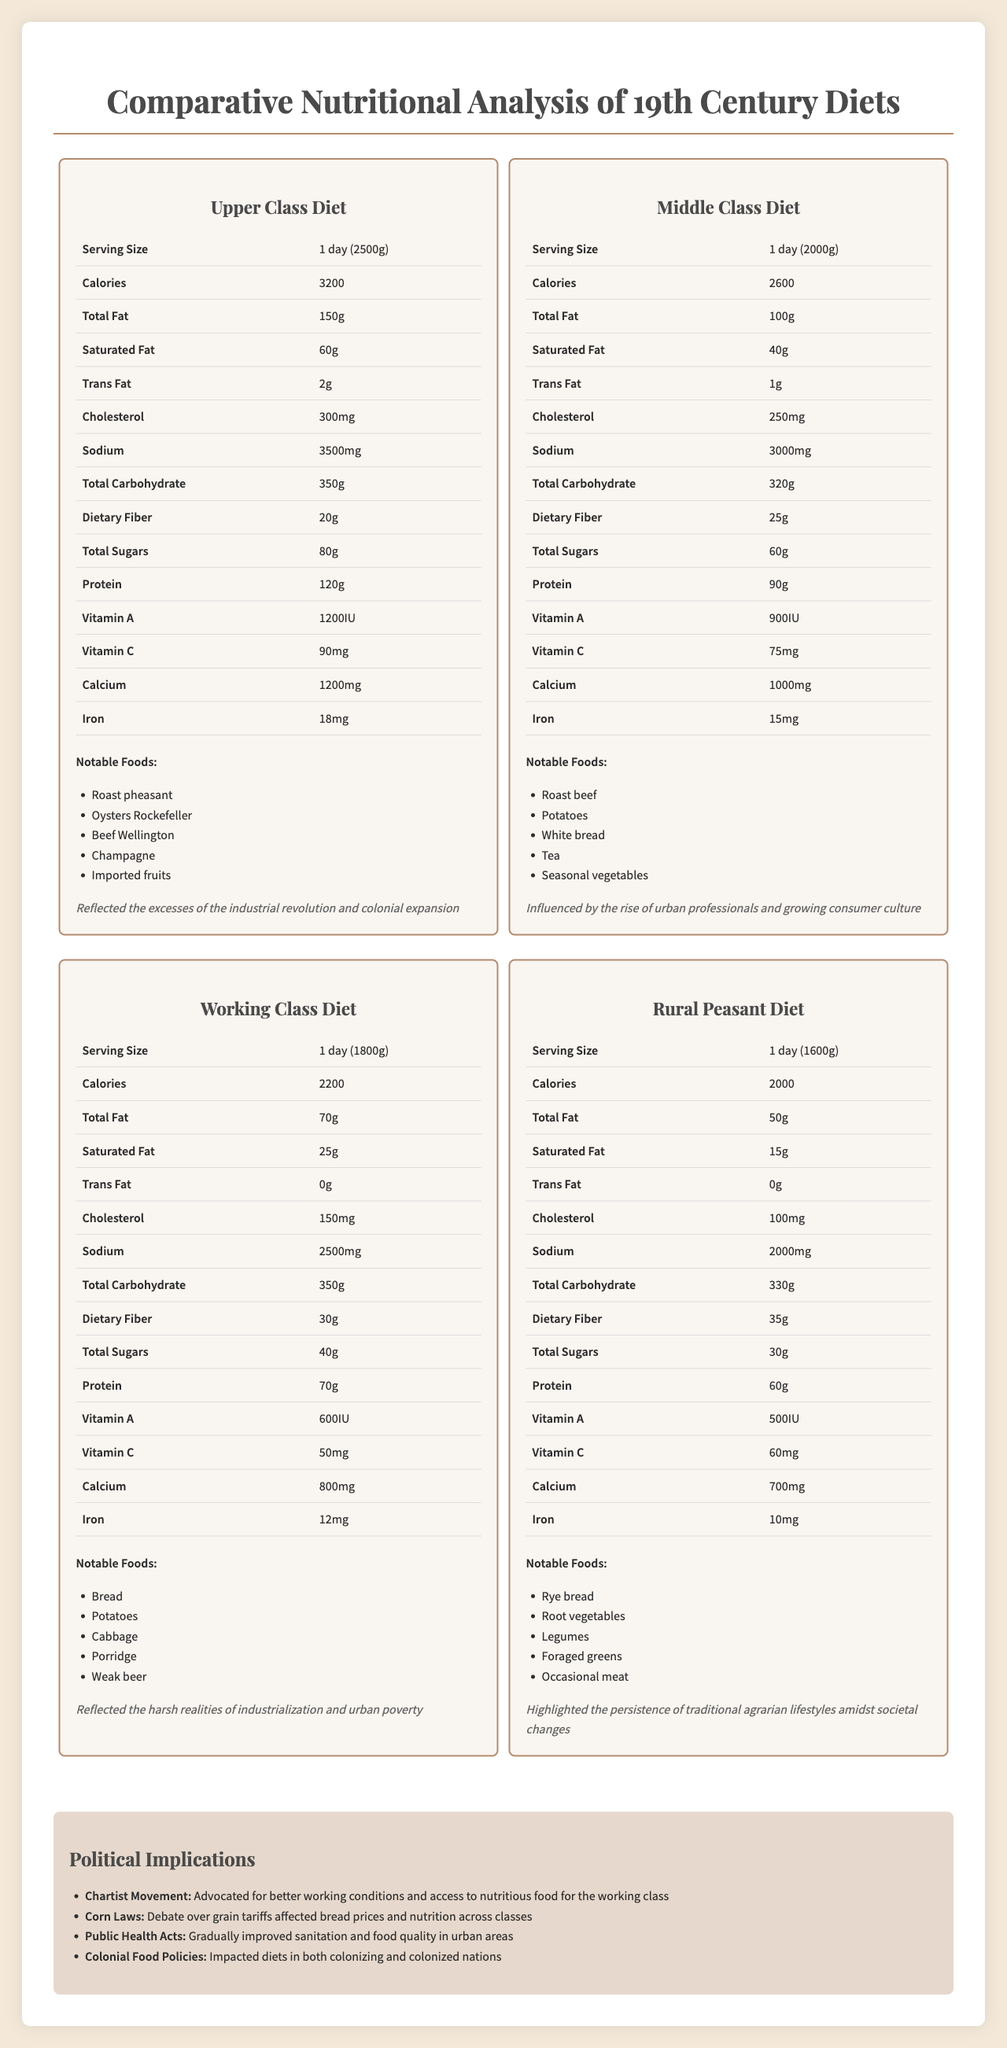What are the calories in a typical upper-class diet? The document specifies that the upper-class diet contains 3200 calories per day.
Answer: 3200 calories List two notable foods in the middle-class diet. According to the document, notable foods in the middle-class diet include roast beef and potatoes.
Answer: Roast beef, Potatoes Which class has the highest protein intake? The document states that the upper-class diet includes 120g of protein, which is the highest among all classes.
Answer: Upper class What is the serving size of a rural peasant diet? The rural peasant diet has a serving size of 1 day (1600g), as mentioned in the document.
Answer: 1 day (1600g) How much sodium is in the working class diet? The document lists the sodium content for the working class diet as 2500mg.
Answer: 2500mg Which class diet has the least total fat? 
A. Upper Class 
B. Middle Class 
C. Working Class 
D. Rural Peasant The rural peasant diet has the least total fat with 50g.
Answer: D Which of these was a notable food in the upper class diet?
i. Beef Wellington 
ii. Porridge 
iii. Rye Bread 
iv. Potatoes Beef Wellington is listed as a notable food in the upper class diet.
Answer: i Is the saturated fat content of the middle class diet higher than that of the rural peasant diet? The middle class diet has 40g of saturated fat, while the rural peasant diet has 15g.
Answer: Yes Summarize the main idea of the document. The document presents the nutrition facts for diets of upper class, middle class, working class, and rural peasants, examines their notable foods and historical contexts, and discusses political movements and policies that impacted these diets.
Answer: The document provides a comparative nutritional analysis of diets from different social classes in the 19th century, detailing serving sizes, nutrient content, notable foods, historical context, and political implications. How did the Chartist movement relate to diets? The document states that the Chartist Movement pushed for improved working conditions and better access to nutritious food for the working class.
Answer: Advocated for better working conditions and access to nutritious food for the working class What specific types of vitamin content are given in the document across the diet classes? Each class diet lists the content of Vitamin A and Vitamin C in the document.
Answer: Vitamin A and Vitamin C What was one of the political implications discussed? The Public Health Acts were mentioned among the political implications in the document.
Answer: Public Health Acts How many iron milligrams are in the middle class diet? The document mentions that the middle class diet contains 15mg of iron.
Answer: 15mg Who consumed more total carbohydrates, the upper class or the rural peasants? The upper class diet includes 350g of total carbohydrates, while the rural peasant diet includes 330g.
Answer: Upper class What kind of meat was occasionally consumed by rural peasants? The document lists "occasional meat" as one of the notable foods in the rural peasant diet.
Answer: Occasional meat What was the calcium content in the upper-class diet compared to the working class diet? The upper-class diet contains 1200mg of calcium while the working class diet contains 800mg of calcium.
Answer: 1200mg in upper-class compared to 800mg in working class Which type of bread was notable in the working-class diet? The document lists "Bread" as a notable food in the working-class diet.
Answer: Bread How did colonial food policies impact diets, based on this document? The document states that colonial food policies had an impact on diets in both the colonizing and colonized nations.
Answer: Impacted diets in both colonizing and colonized nations Is there sufficient information about the specific proportions of imported fruits in the upper-class diet? The document mentions imported fruits as a notable food in the upper class diet but does not provide specific proportions.
Answer: Not enough information 